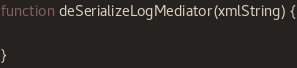<code> <loc_0><loc_0><loc_500><loc_500><_JavaScript_>
function deSerializeLogMediator(xmlString) {

}


</code> 